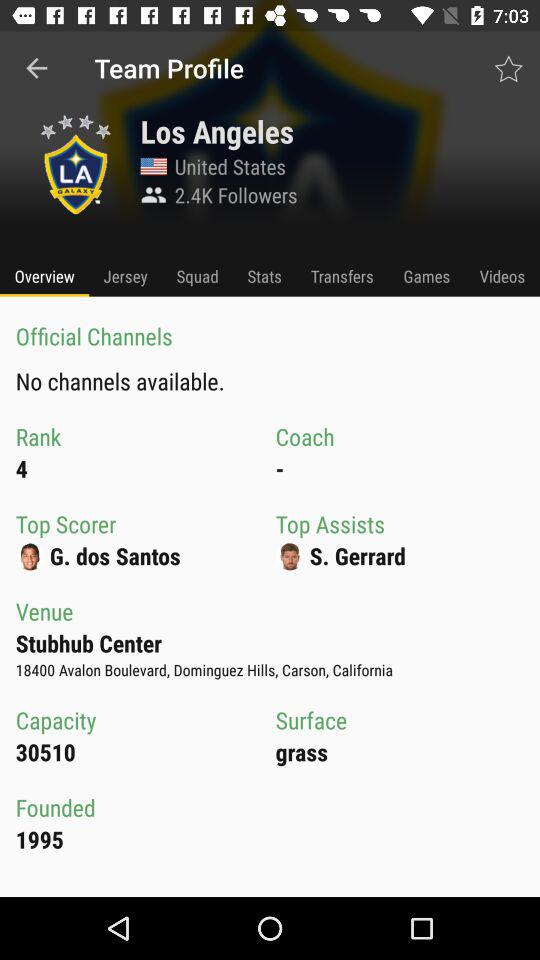What is the name of the team? The name of the team is "LA GALAXY". 